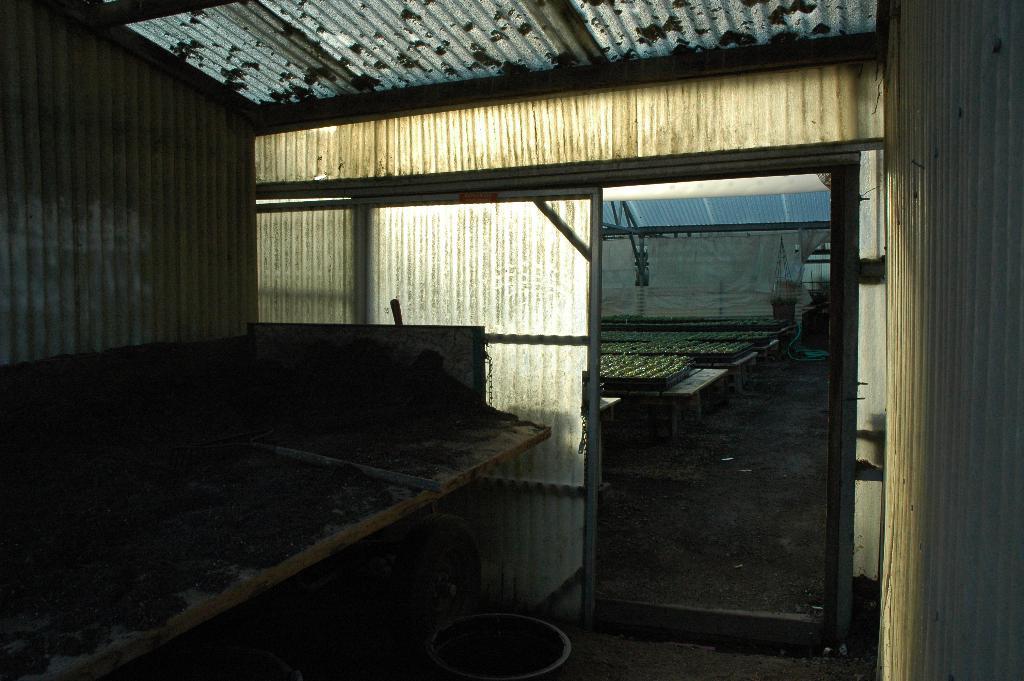In one or two sentences, can you explain what this image depicts? In the picture I can see closed placed, which is looks like a shed. 